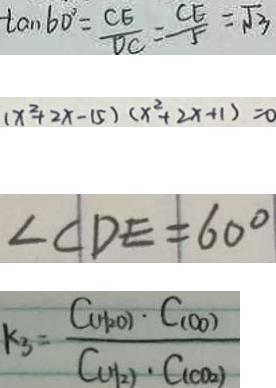<formula> <loc_0><loc_0><loc_500><loc_500>\tan 6 0 ^ { \circ } = \frac { C E } { D C } = \frac { C E } { 5 } = \sqrt { 3 } 
 ( x ^ { 2 } + 2 x - 1 5 ) ( x ^ { 2 } + 2 x + 1 ) = 0 
 \angle C D E = 6 0 ^ { \circ } 
 k _ { 3 } = \frac { C _ { ( H _ { 2 } O ) } \cdot C _ { ( o o ) } } { C _ { ( H _ { 2 } ) } \cdot C _ { ( C O _ { 2 } ) } }</formula> 